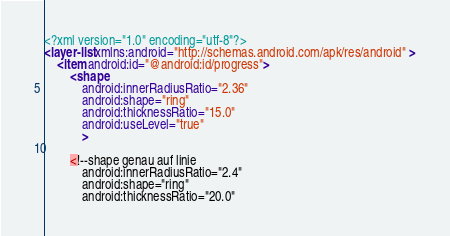<code> <loc_0><loc_0><loc_500><loc_500><_XML_><?xml version="1.0" encoding="utf-8"?>
<layer-list xmlns:android="http://schemas.android.com/apk/res/android" >
    <item android:id="@android:id/progress">
        <shape
            android:innerRadiusRatio="2.36"
            android:shape="ring"
            android:thicknessRatio="15.0"
            android:useLevel="true"
            >

        <!--shape genau auf linie
            android:innerRadiusRatio="2.4"
            android:shape="ring"
            android:thicknessRatio="20.0"</code> 